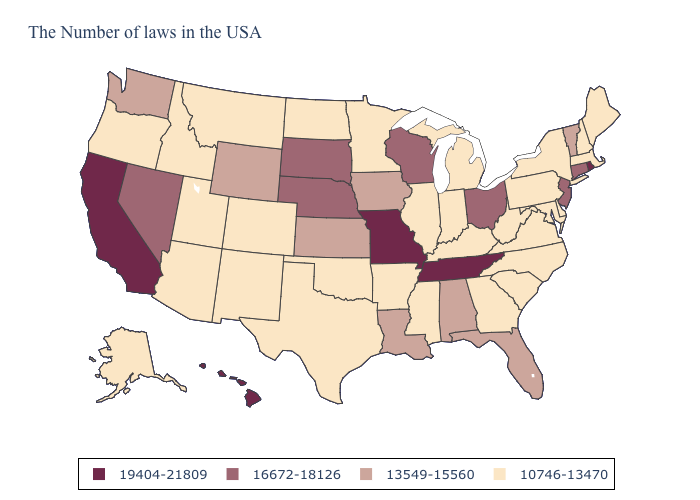Is the legend a continuous bar?
Concise answer only. No. Name the states that have a value in the range 10746-13470?
Give a very brief answer. Maine, Massachusetts, New Hampshire, New York, Delaware, Maryland, Pennsylvania, Virginia, North Carolina, South Carolina, West Virginia, Georgia, Michigan, Kentucky, Indiana, Illinois, Mississippi, Arkansas, Minnesota, Oklahoma, Texas, North Dakota, Colorado, New Mexico, Utah, Montana, Arizona, Idaho, Oregon, Alaska. What is the value of Massachusetts?
Short answer required. 10746-13470. What is the lowest value in the USA?
Answer briefly. 10746-13470. What is the lowest value in states that border Arkansas?
Give a very brief answer. 10746-13470. Name the states that have a value in the range 16672-18126?
Answer briefly. Connecticut, New Jersey, Ohio, Wisconsin, Nebraska, South Dakota, Nevada. What is the highest value in states that border California?
Quick response, please. 16672-18126. Among the states that border Massachusetts , does Rhode Island have the highest value?
Write a very short answer. Yes. What is the lowest value in the South?
Quick response, please. 10746-13470. Among the states that border Pennsylvania , does Ohio have the lowest value?
Write a very short answer. No. What is the highest value in the USA?
Concise answer only. 19404-21809. How many symbols are there in the legend?
Write a very short answer. 4. Which states have the lowest value in the Northeast?
Write a very short answer. Maine, Massachusetts, New Hampshire, New York, Pennsylvania. What is the lowest value in the USA?
Short answer required. 10746-13470. 